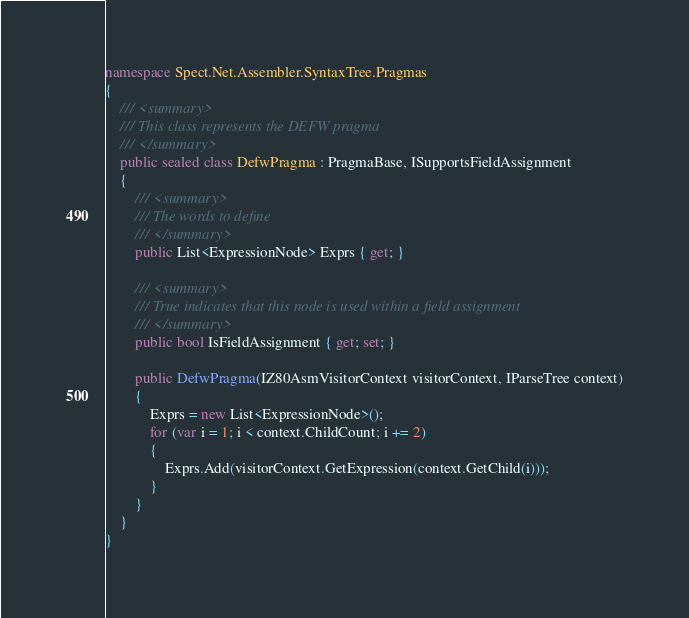Convert code to text. <code><loc_0><loc_0><loc_500><loc_500><_C#_>namespace Spect.Net.Assembler.SyntaxTree.Pragmas
{
    /// <summary>
    /// This class represents the DEFW pragma
    /// </summary>
    public sealed class DefwPragma : PragmaBase, ISupportsFieldAssignment
    {
        /// <summary>
        /// The words to define
        /// </summary>
        public List<ExpressionNode> Exprs { get; }

        /// <summary>
        /// True indicates that this node is used within a field assignment
        /// </summary>
        public bool IsFieldAssignment { get; set; }

        public DefwPragma(IZ80AsmVisitorContext visitorContext, IParseTree context)
        {
            Exprs = new List<ExpressionNode>();
            for (var i = 1; i < context.ChildCount; i += 2)
            {
                Exprs.Add(visitorContext.GetExpression(context.GetChild(i)));
            }
        }
    }
}</code> 